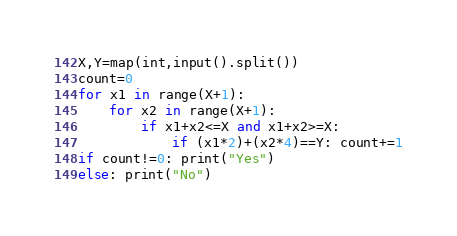<code> <loc_0><loc_0><loc_500><loc_500><_Python_>X,Y=map(int,input().split())
count=0
for x1 in range(X+1):
    for x2 in range(X+1):
        if x1+x2<=X and x1+x2>=X:
            if (x1*2)+(x2*4)==Y: count+=1
if count!=0: print("Yes")
else: print("No")</code> 